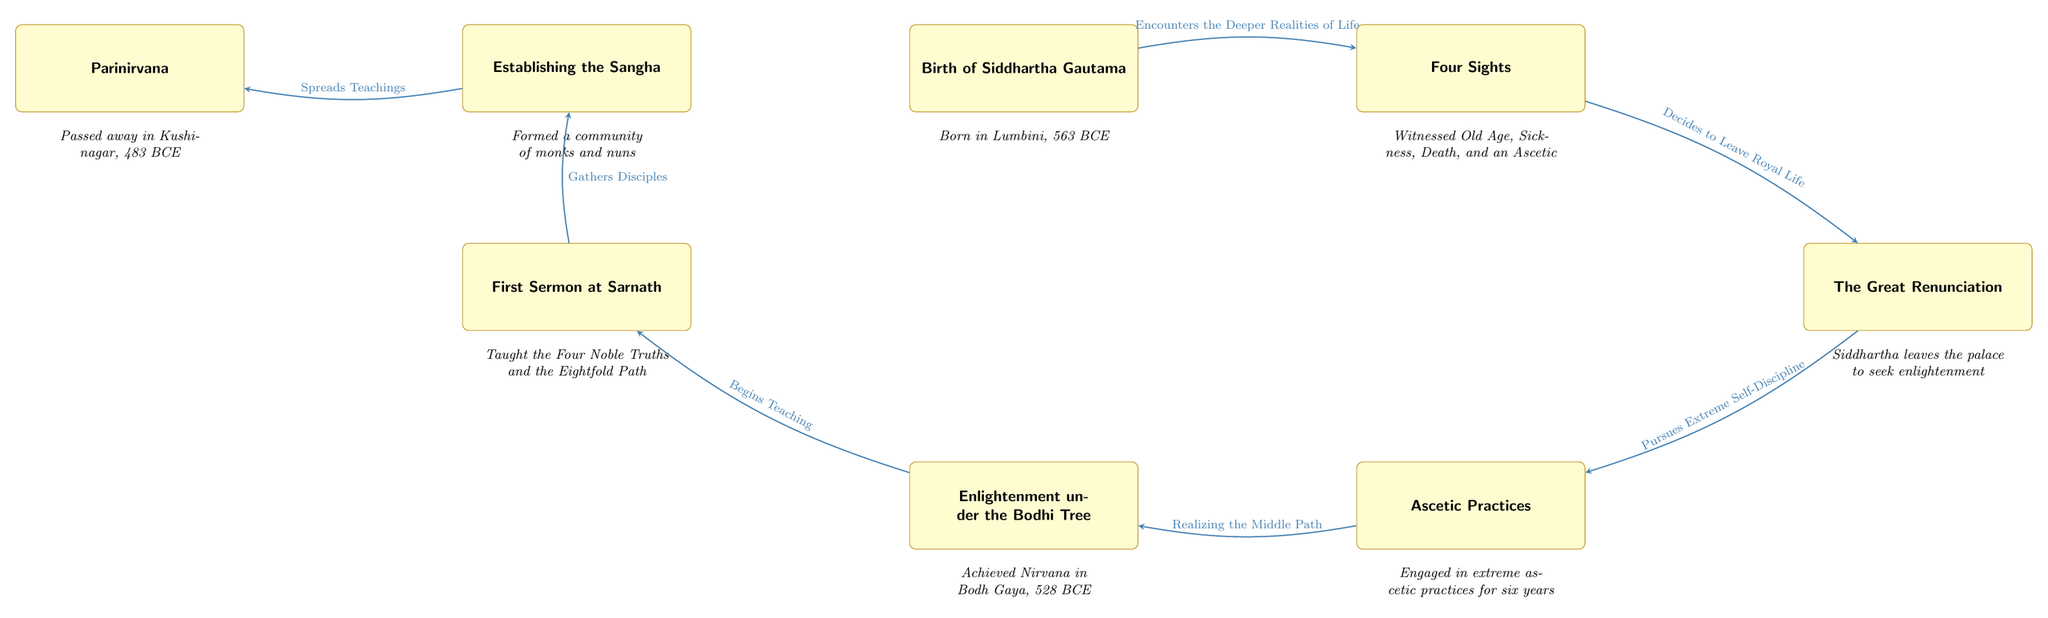What year did Siddhartha Gautama achieve enlightenment? The diagram specifies that Siddhartha Gautama achieved enlightenment under the Bodhi Tree in Bodh Gaya in the year 528 BCE. This detail is directly stated in the node for enlightenment.
Answer: 528 BCE What event follows the Great Renunciation? The arrow directed from the node for the Great Renunciation leads to the Ascetic Practices node, indicating that the ascetic practices directly follow the Great Renunciation.
Answer: Ascetic Practices How many main events are listed in the diagram? By counting the event nodes in the diagram, we find a total of seven key events: Birth, Four Sights, Great Renunciation, Ascetic Practices, Enlightenment, First Sermon, and Parinirvana.
Answer: 7 What did Siddhartha do after achieving enlightenment? The diagram shows an arrow leading from the Enlightenment node to the First Sermon node, indicating that Siddhartha Gautama began teaching after achieving enlightenment.
Answer: Begins Teaching What significant realization occurred during the Ascetic Practices? The node related to enlightenment indicates that following the ascetic practices, Siddhartha realized the Middle Path, which was a significant turning point in his journey. Therefore, the realization during the Ascetic Practices is the Middle Path.
Answer: Middle Path What do the Four Sights refer to? The Four Sights refer to the experiences Siddhartha witnessed: Old Age, Sickness, Death, and an Ascetic. This is explicitly detailed in the description connected to the node for Four Sights.
Answer: Old Age, Sickness, Death, and an Ascetic What is the final event in Siddhartha's life according to the diagram? The Parinirvana node, which indicates Siddhartha Gautama's passing away in Kushinagar, is the last event listed in the diagram, establishing it as the final event in his life.
Answer: Parinirvana 